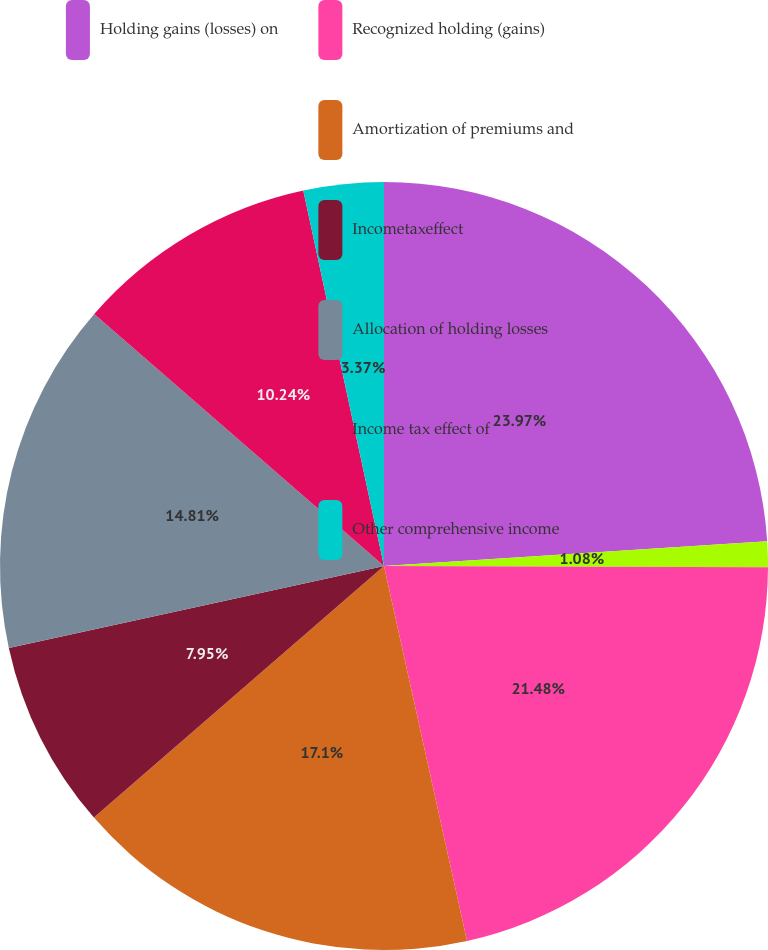Convert chart to OTSL. <chart><loc_0><loc_0><loc_500><loc_500><pie_chart><fcel>Holding gains (losses) on<fcel>Unnamed: 1<fcel>Recognized holding (gains)<fcel>Amortization of premiums and<fcel>Incometaxeffect<fcel>Allocation of holding losses<fcel>Income tax effect of<fcel>Other comprehensive income<nl><fcel>23.97%<fcel>1.08%<fcel>21.48%<fcel>17.1%<fcel>7.95%<fcel>14.81%<fcel>10.24%<fcel>3.37%<nl></chart> 